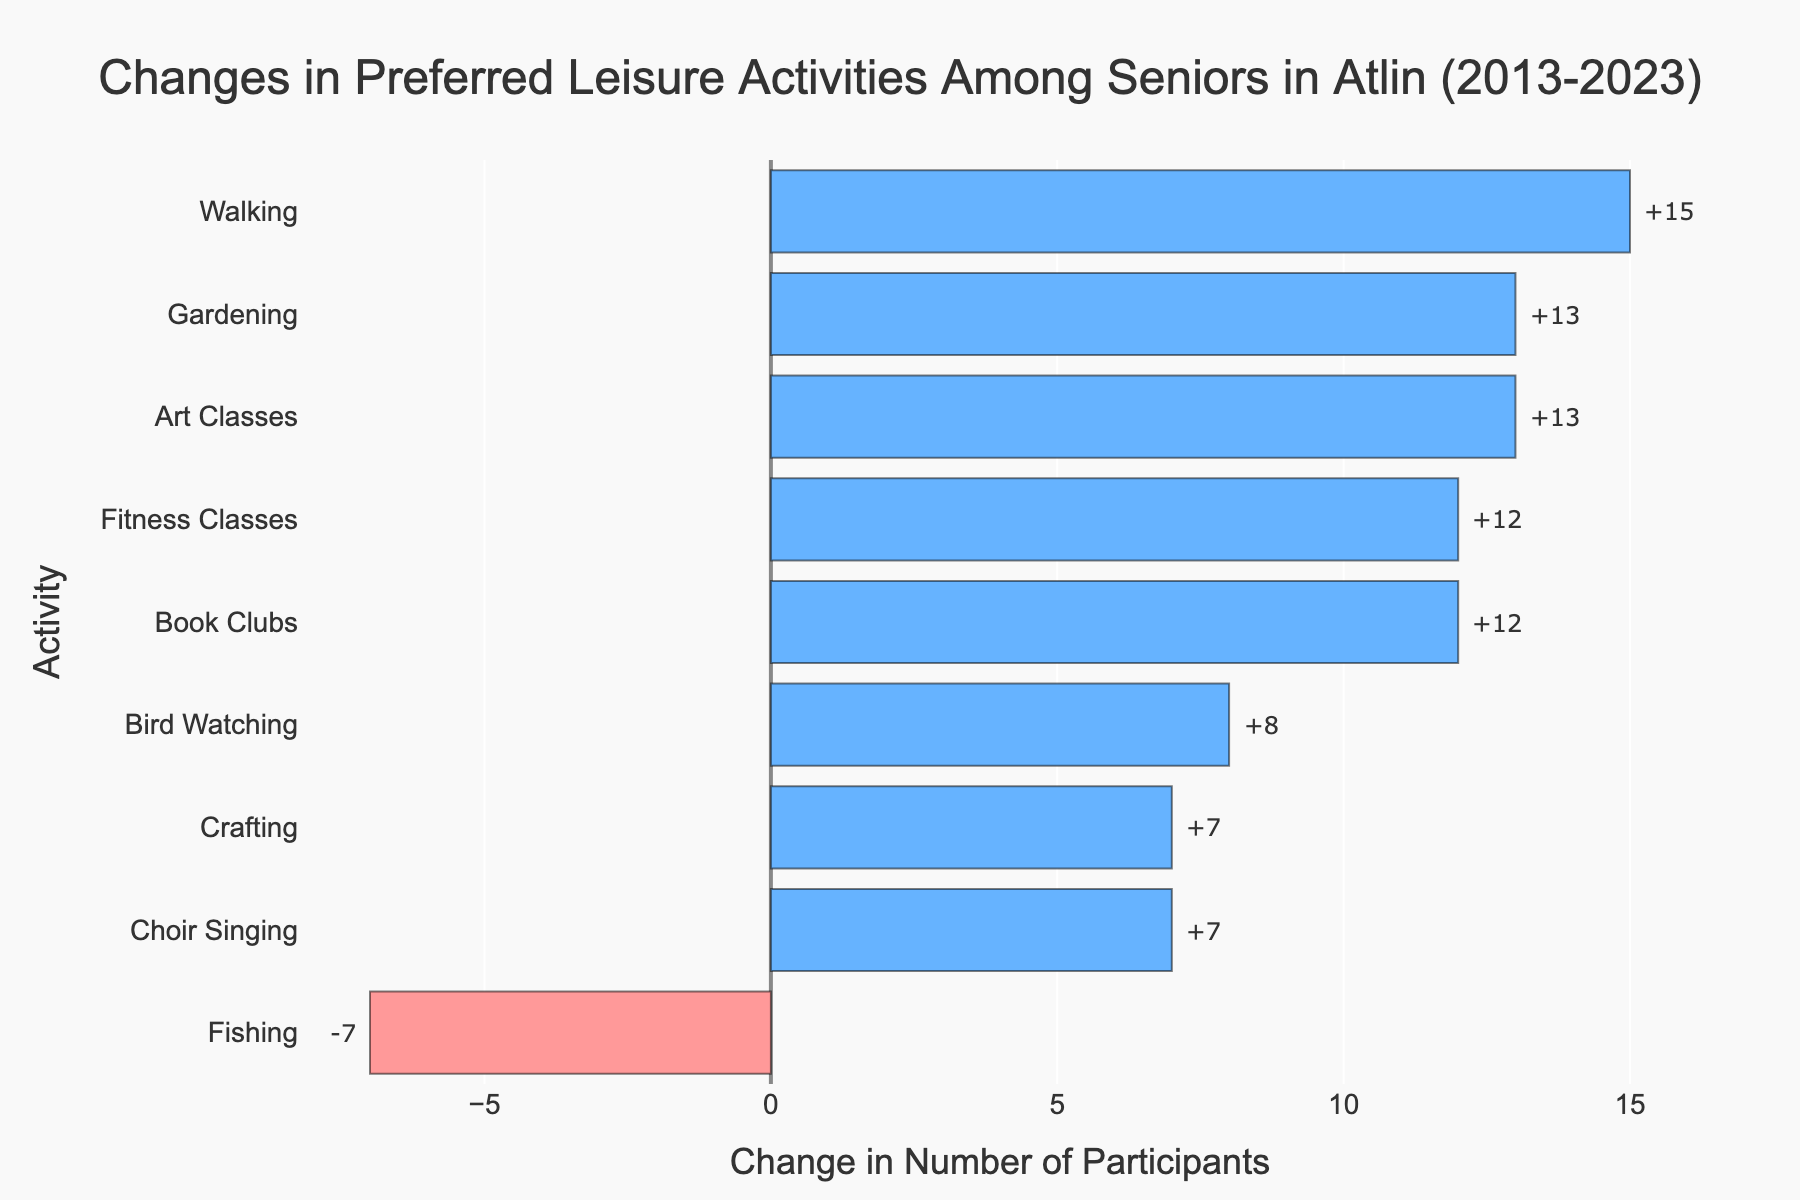Which activity showed the largest increase in participants from 2013 to 2023? Find the activity with the highest positive change in participants by looking at the end of the longest blue bar.
Answer: Walking Which activity decreased in popularity from 2013 to 2023? Identify the activity with a negative change by looking for the bar that extends to the left and is red.
Answer: Fishing How many more people participated in Gardening in 2023 compared to 2013? Look at the bar for Gardening and note the value.
Answer: 13 Which two activities had the same number of participants in 2023? Observe the end of bars to check if two of them align vertically at the same point.
Answer: Book Clubs and Walking Between Bird Watching and Choir Singing, which had a bigger increase in participants? Compare the lengths of the blue bars for Bird Watching and Choir Singing to see which is longer.
Answer: Bird Watching What is the total increase in participants for all the activities combined? Add up all positive and negative changes from the bars: (+13) + (+15) + (+8) + (+13) + (-7) + (+12) + (+7) + (+12) + (+7) = 80
Answer: 80 Which activity had exactly 7 more participants in 2023 than in 2013? Look for the bar where the change value is +7.
Answer: Choir Singing How many activities increased in popularity over the past decade? Count the number of blue bars. There are 8 blue bars in total.
Answer: 8 